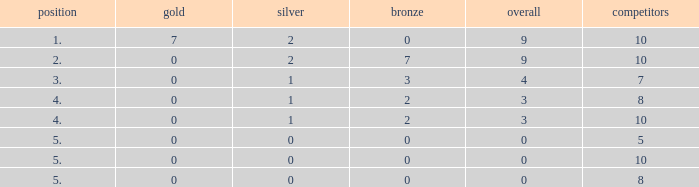What is the total number of Participants that has Silver that's smaller than 0? None. 